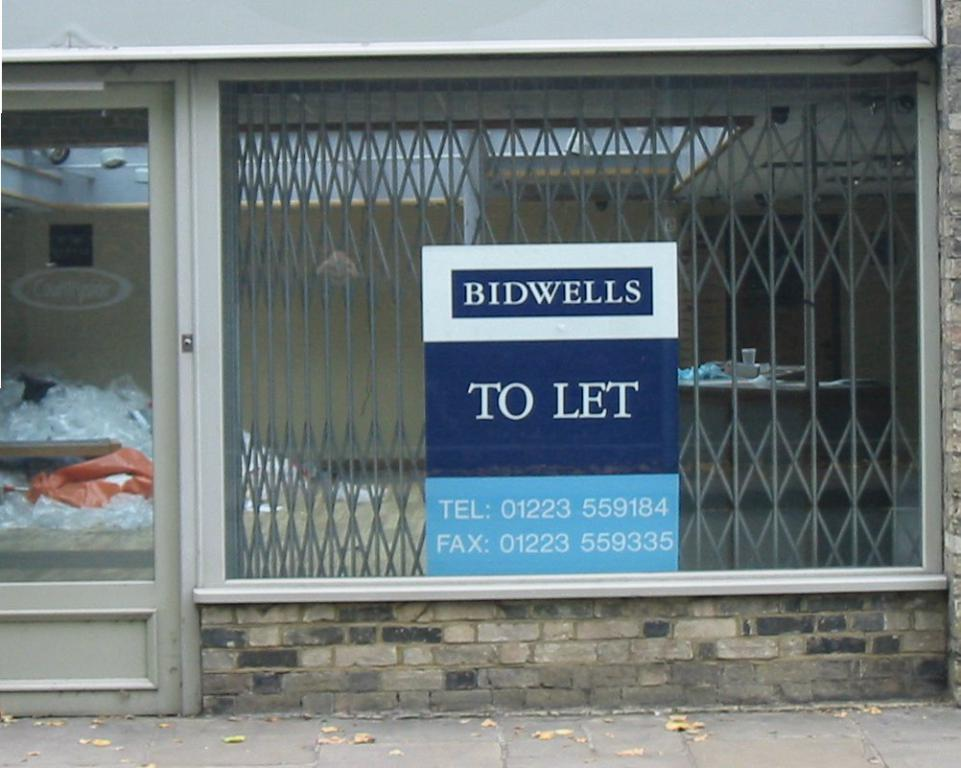What is the main subject of the image? The main subject of the image is a "to let" board. What information is provided below the "to let" board? There is writing below the "to let" board. What can be seen behind the "to let" board? There is a fence behind the "to let" board. What type of amusement can be seen in the image? There is no amusement present in the image; it features a "to let" board with writing and a fence. What color is the wool used to make the fence in the image? There is no wool or fence made of wool in the image; it features a fence made of a different material. 